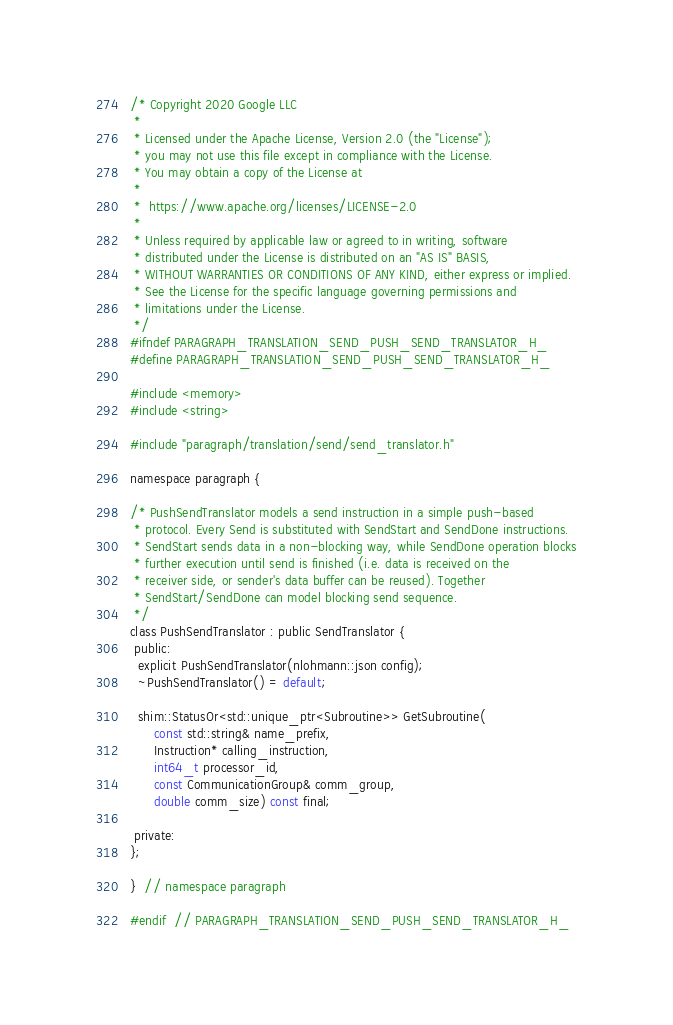Convert code to text. <code><loc_0><loc_0><loc_500><loc_500><_C_>/* Copyright 2020 Google LLC
 *
 * Licensed under the Apache License, Version 2.0 (the "License");
 * you may not use this file except in compliance with the License.
 * You may obtain a copy of the License at
 *
 *  https://www.apache.org/licenses/LICENSE-2.0
 *
 * Unless required by applicable law or agreed to in writing, software
 * distributed under the License is distributed on an "AS IS" BASIS,
 * WITHOUT WARRANTIES OR CONDITIONS OF ANY KIND, either express or implied.
 * See the License for the specific language governing permissions and
 * limitations under the License.
 */
#ifndef PARAGRAPH_TRANSLATION_SEND_PUSH_SEND_TRANSLATOR_H_
#define PARAGRAPH_TRANSLATION_SEND_PUSH_SEND_TRANSLATOR_H_

#include <memory>
#include <string>

#include "paragraph/translation/send/send_translator.h"

namespace paragraph {

/* PushSendTranslator models a send instruction in a simple push-based
 * protocol. Every Send is substituted with SendStart and SendDone instructions.
 * SendStart sends data in a non-blocking way, while SendDone operation blocks
 * further execution until send is finished (i.e. data is received on the
 * receiver side, or sender's data buffer can be reused). Together
 * SendStart/SendDone can model blocking send sequence.
 */
class PushSendTranslator : public SendTranslator {
 public:
  explicit PushSendTranslator(nlohmann::json config);
  ~PushSendTranslator() = default;

  shim::StatusOr<std::unique_ptr<Subroutine>> GetSubroutine(
      const std::string& name_prefix,
      Instruction* calling_instruction,
      int64_t processor_id,
      const CommunicationGroup& comm_group,
      double comm_size) const final;

 private:
};

}  // namespace paragraph

#endif  // PARAGRAPH_TRANSLATION_SEND_PUSH_SEND_TRANSLATOR_H_
</code> 